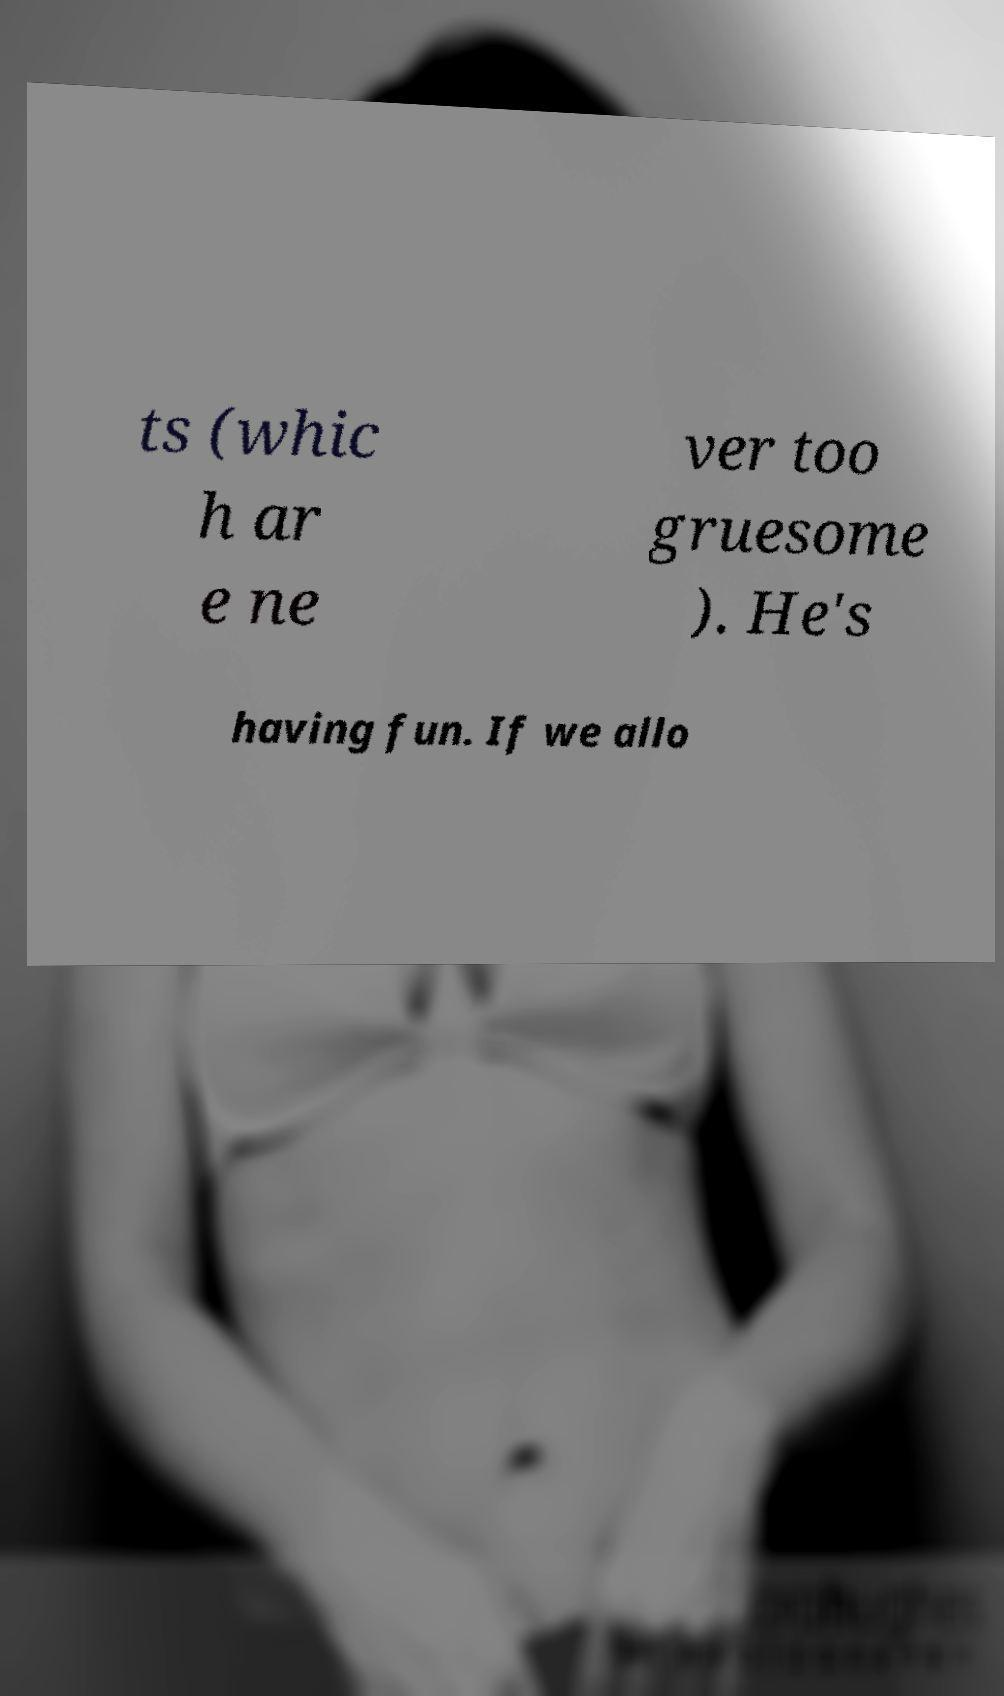I need the written content from this picture converted into text. Can you do that? ts (whic h ar e ne ver too gruesome ). He's having fun. If we allo 